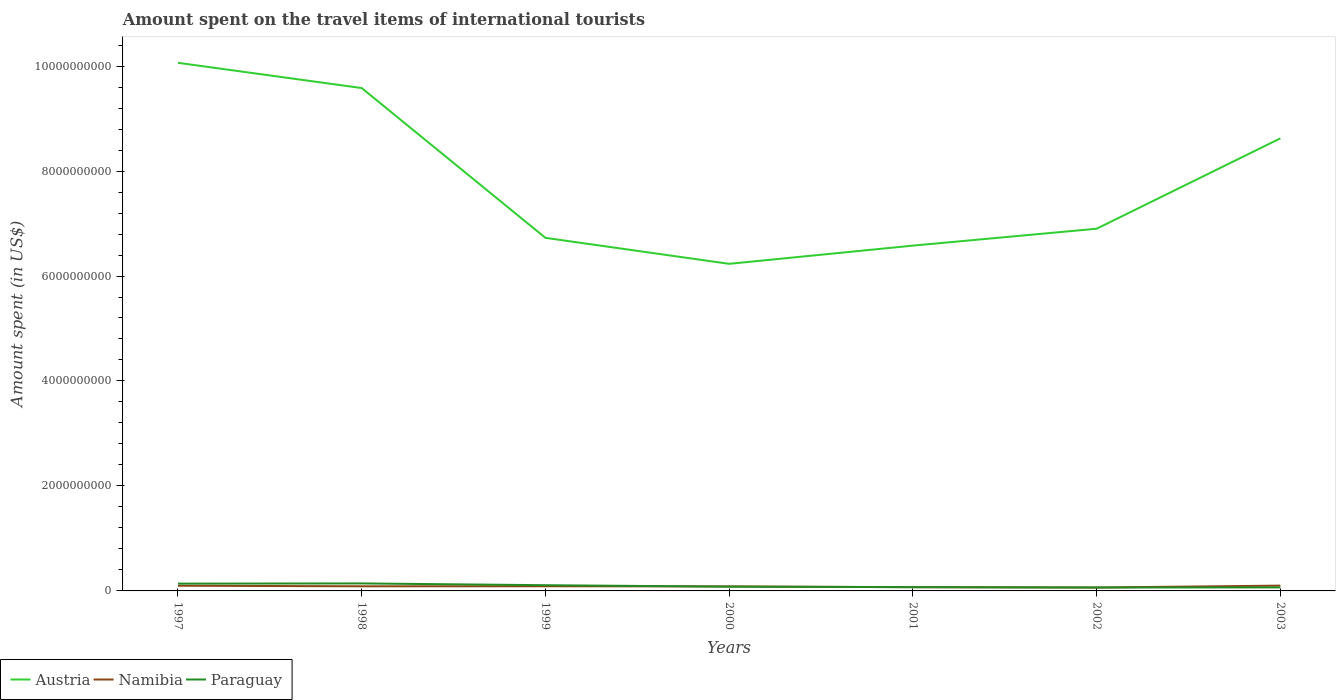How many different coloured lines are there?
Ensure brevity in your answer.  3. Does the line corresponding to Austria intersect with the line corresponding to Paraguay?
Your response must be concise. No. Across all years, what is the maximum amount spent on the travel items of international tourists in Austria?
Offer a very short reply. 6.23e+09. What is the total amount spent on the travel items of international tourists in Paraguay in the graph?
Your answer should be compact. 6.70e+07. What is the difference between the highest and the second highest amount spent on the travel items of international tourists in Paraguay?
Your answer should be very brief. 7.80e+07. What is the difference between the highest and the lowest amount spent on the travel items of international tourists in Austria?
Provide a short and direct response. 3. Is the amount spent on the travel items of international tourists in Paraguay strictly greater than the amount spent on the travel items of international tourists in Namibia over the years?
Provide a succinct answer. No. How many lines are there?
Provide a succinct answer. 3. How many years are there in the graph?
Offer a very short reply. 7. What is the difference between two consecutive major ticks on the Y-axis?
Make the answer very short. 2.00e+09. Does the graph contain any zero values?
Provide a short and direct response. No. Does the graph contain grids?
Offer a very short reply. No. Where does the legend appear in the graph?
Give a very brief answer. Bottom left. How many legend labels are there?
Offer a terse response. 3. How are the legend labels stacked?
Offer a terse response. Horizontal. What is the title of the graph?
Offer a terse response. Amount spent on the travel items of international tourists. What is the label or title of the X-axis?
Give a very brief answer. Years. What is the label or title of the Y-axis?
Offer a terse response. Amount spent (in US$). What is the Amount spent (in US$) in Austria in 1997?
Make the answer very short. 1.01e+1. What is the Amount spent (in US$) of Namibia in 1997?
Offer a terse response. 9.90e+07. What is the Amount spent (in US$) of Paraguay in 1997?
Your answer should be very brief. 1.39e+08. What is the Amount spent (in US$) in Austria in 1998?
Keep it short and to the point. 9.58e+09. What is the Amount spent (in US$) in Namibia in 1998?
Provide a short and direct response. 8.80e+07. What is the Amount spent (in US$) in Paraguay in 1998?
Ensure brevity in your answer.  1.43e+08. What is the Amount spent (in US$) in Austria in 1999?
Your answer should be very brief. 6.73e+09. What is the Amount spent (in US$) in Namibia in 1999?
Ensure brevity in your answer.  8.90e+07. What is the Amount spent (in US$) in Paraguay in 1999?
Offer a very short reply. 1.09e+08. What is the Amount spent (in US$) of Austria in 2000?
Keep it short and to the point. 6.23e+09. What is the Amount spent (in US$) in Namibia in 2000?
Your answer should be very brief. 8.60e+07. What is the Amount spent (in US$) of Paraguay in 2000?
Keep it short and to the point. 8.10e+07. What is the Amount spent (in US$) of Austria in 2001?
Offer a very short reply. 6.58e+09. What is the Amount spent (in US$) in Namibia in 2001?
Keep it short and to the point. 7.10e+07. What is the Amount spent (in US$) in Paraguay in 2001?
Your answer should be compact. 7.20e+07. What is the Amount spent (in US$) of Austria in 2002?
Offer a very short reply. 6.90e+09. What is the Amount spent (in US$) of Namibia in 2002?
Provide a succinct answer. 6.50e+07. What is the Amount spent (in US$) in Paraguay in 2002?
Give a very brief answer. 6.50e+07. What is the Amount spent (in US$) in Austria in 2003?
Your answer should be very brief. 8.62e+09. What is the Amount spent (in US$) in Namibia in 2003?
Provide a succinct answer. 1.01e+08. What is the Amount spent (in US$) in Paraguay in 2003?
Offer a very short reply. 6.70e+07. Across all years, what is the maximum Amount spent (in US$) of Austria?
Your answer should be compact. 1.01e+1. Across all years, what is the maximum Amount spent (in US$) of Namibia?
Offer a terse response. 1.01e+08. Across all years, what is the maximum Amount spent (in US$) of Paraguay?
Offer a very short reply. 1.43e+08. Across all years, what is the minimum Amount spent (in US$) of Austria?
Your response must be concise. 6.23e+09. Across all years, what is the minimum Amount spent (in US$) of Namibia?
Provide a short and direct response. 6.50e+07. Across all years, what is the minimum Amount spent (in US$) of Paraguay?
Offer a very short reply. 6.50e+07. What is the total Amount spent (in US$) in Austria in the graph?
Offer a very short reply. 5.47e+1. What is the total Amount spent (in US$) in Namibia in the graph?
Give a very brief answer. 5.99e+08. What is the total Amount spent (in US$) of Paraguay in the graph?
Your answer should be very brief. 6.76e+08. What is the difference between the Amount spent (in US$) in Austria in 1997 and that in 1998?
Keep it short and to the point. 4.81e+08. What is the difference between the Amount spent (in US$) in Namibia in 1997 and that in 1998?
Offer a terse response. 1.10e+07. What is the difference between the Amount spent (in US$) of Paraguay in 1997 and that in 1998?
Give a very brief answer. -4.00e+06. What is the difference between the Amount spent (in US$) in Austria in 1997 and that in 1999?
Your answer should be compact. 3.34e+09. What is the difference between the Amount spent (in US$) in Paraguay in 1997 and that in 1999?
Your response must be concise. 3.00e+07. What is the difference between the Amount spent (in US$) of Austria in 1997 and that in 2000?
Your answer should be compact. 3.83e+09. What is the difference between the Amount spent (in US$) in Namibia in 1997 and that in 2000?
Make the answer very short. 1.30e+07. What is the difference between the Amount spent (in US$) of Paraguay in 1997 and that in 2000?
Your response must be concise. 5.80e+07. What is the difference between the Amount spent (in US$) of Austria in 1997 and that in 2001?
Provide a succinct answer. 3.48e+09. What is the difference between the Amount spent (in US$) of Namibia in 1997 and that in 2001?
Your response must be concise. 2.80e+07. What is the difference between the Amount spent (in US$) of Paraguay in 1997 and that in 2001?
Offer a very short reply. 6.70e+07. What is the difference between the Amount spent (in US$) of Austria in 1997 and that in 2002?
Ensure brevity in your answer.  3.16e+09. What is the difference between the Amount spent (in US$) of Namibia in 1997 and that in 2002?
Keep it short and to the point. 3.40e+07. What is the difference between the Amount spent (in US$) in Paraguay in 1997 and that in 2002?
Offer a very short reply. 7.40e+07. What is the difference between the Amount spent (in US$) of Austria in 1997 and that in 2003?
Your response must be concise. 1.44e+09. What is the difference between the Amount spent (in US$) in Paraguay in 1997 and that in 2003?
Your response must be concise. 7.20e+07. What is the difference between the Amount spent (in US$) of Austria in 1998 and that in 1999?
Your answer should be very brief. 2.85e+09. What is the difference between the Amount spent (in US$) of Paraguay in 1998 and that in 1999?
Keep it short and to the point. 3.40e+07. What is the difference between the Amount spent (in US$) of Austria in 1998 and that in 2000?
Your response must be concise. 3.35e+09. What is the difference between the Amount spent (in US$) in Namibia in 1998 and that in 2000?
Keep it short and to the point. 2.00e+06. What is the difference between the Amount spent (in US$) in Paraguay in 1998 and that in 2000?
Offer a terse response. 6.20e+07. What is the difference between the Amount spent (in US$) of Austria in 1998 and that in 2001?
Offer a very short reply. 3.00e+09. What is the difference between the Amount spent (in US$) in Namibia in 1998 and that in 2001?
Your answer should be very brief. 1.70e+07. What is the difference between the Amount spent (in US$) in Paraguay in 1998 and that in 2001?
Provide a short and direct response. 7.10e+07. What is the difference between the Amount spent (in US$) in Austria in 1998 and that in 2002?
Provide a short and direct response. 2.68e+09. What is the difference between the Amount spent (in US$) of Namibia in 1998 and that in 2002?
Offer a terse response. 2.30e+07. What is the difference between the Amount spent (in US$) of Paraguay in 1998 and that in 2002?
Offer a very short reply. 7.80e+07. What is the difference between the Amount spent (in US$) in Austria in 1998 and that in 2003?
Offer a very short reply. 9.58e+08. What is the difference between the Amount spent (in US$) in Namibia in 1998 and that in 2003?
Your answer should be compact. -1.30e+07. What is the difference between the Amount spent (in US$) of Paraguay in 1998 and that in 2003?
Provide a succinct answer. 7.60e+07. What is the difference between the Amount spent (in US$) in Austria in 1999 and that in 2000?
Ensure brevity in your answer.  4.95e+08. What is the difference between the Amount spent (in US$) in Paraguay in 1999 and that in 2000?
Make the answer very short. 2.80e+07. What is the difference between the Amount spent (in US$) of Austria in 1999 and that in 2001?
Your answer should be compact. 1.48e+08. What is the difference between the Amount spent (in US$) of Namibia in 1999 and that in 2001?
Provide a succinct answer. 1.80e+07. What is the difference between the Amount spent (in US$) of Paraguay in 1999 and that in 2001?
Your response must be concise. 3.70e+07. What is the difference between the Amount spent (in US$) of Austria in 1999 and that in 2002?
Your response must be concise. -1.74e+08. What is the difference between the Amount spent (in US$) in Namibia in 1999 and that in 2002?
Make the answer very short. 2.40e+07. What is the difference between the Amount spent (in US$) in Paraguay in 1999 and that in 2002?
Your response must be concise. 4.40e+07. What is the difference between the Amount spent (in US$) of Austria in 1999 and that in 2003?
Provide a short and direct response. -1.90e+09. What is the difference between the Amount spent (in US$) of Namibia in 1999 and that in 2003?
Provide a succinct answer. -1.20e+07. What is the difference between the Amount spent (in US$) of Paraguay in 1999 and that in 2003?
Your answer should be compact. 4.20e+07. What is the difference between the Amount spent (in US$) in Austria in 2000 and that in 2001?
Provide a short and direct response. -3.47e+08. What is the difference between the Amount spent (in US$) in Namibia in 2000 and that in 2001?
Give a very brief answer. 1.50e+07. What is the difference between the Amount spent (in US$) of Paraguay in 2000 and that in 2001?
Provide a succinct answer. 9.00e+06. What is the difference between the Amount spent (in US$) of Austria in 2000 and that in 2002?
Give a very brief answer. -6.69e+08. What is the difference between the Amount spent (in US$) of Namibia in 2000 and that in 2002?
Provide a short and direct response. 2.10e+07. What is the difference between the Amount spent (in US$) of Paraguay in 2000 and that in 2002?
Keep it short and to the point. 1.60e+07. What is the difference between the Amount spent (in US$) of Austria in 2000 and that in 2003?
Provide a short and direct response. -2.39e+09. What is the difference between the Amount spent (in US$) in Namibia in 2000 and that in 2003?
Your answer should be very brief. -1.50e+07. What is the difference between the Amount spent (in US$) of Paraguay in 2000 and that in 2003?
Your answer should be compact. 1.40e+07. What is the difference between the Amount spent (in US$) in Austria in 2001 and that in 2002?
Your answer should be compact. -3.22e+08. What is the difference between the Amount spent (in US$) of Namibia in 2001 and that in 2002?
Provide a succinct answer. 6.00e+06. What is the difference between the Amount spent (in US$) of Austria in 2001 and that in 2003?
Your answer should be compact. -2.04e+09. What is the difference between the Amount spent (in US$) of Namibia in 2001 and that in 2003?
Provide a succinct answer. -3.00e+07. What is the difference between the Amount spent (in US$) in Austria in 2002 and that in 2003?
Give a very brief answer. -1.72e+09. What is the difference between the Amount spent (in US$) in Namibia in 2002 and that in 2003?
Provide a short and direct response. -3.60e+07. What is the difference between the Amount spent (in US$) of Austria in 1997 and the Amount spent (in US$) of Namibia in 1998?
Your answer should be very brief. 9.97e+09. What is the difference between the Amount spent (in US$) in Austria in 1997 and the Amount spent (in US$) in Paraguay in 1998?
Provide a short and direct response. 9.92e+09. What is the difference between the Amount spent (in US$) in Namibia in 1997 and the Amount spent (in US$) in Paraguay in 1998?
Ensure brevity in your answer.  -4.40e+07. What is the difference between the Amount spent (in US$) in Austria in 1997 and the Amount spent (in US$) in Namibia in 1999?
Offer a terse response. 9.97e+09. What is the difference between the Amount spent (in US$) of Austria in 1997 and the Amount spent (in US$) of Paraguay in 1999?
Your answer should be compact. 9.95e+09. What is the difference between the Amount spent (in US$) of Namibia in 1997 and the Amount spent (in US$) of Paraguay in 1999?
Give a very brief answer. -1.00e+07. What is the difference between the Amount spent (in US$) of Austria in 1997 and the Amount spent (in US$) of Namibia in 2000?
Ensure brevity in your answer.  9.98e+09. What is the difference between the Amount spent (in US$) of Austria in 1997 and the Amount spent (in US$) of Paraguay in 2000?
Make the answer very short. 9.98e+09. What is the difference between the Amount spent (in US$) in Namibia in 1997 and the Amount spent (in US$) in Paraguay in 2000?
Make the answer very short. 1.80e+07. What is the difference between the Amount spent (in US$) of Austria in 1997 and the Amount spent (in US$) of Namibia in 2001?
Keep it short and to the point. 9.99e+09. What is the difference between the Amount spent (in US$) in Austria in 1997 and the Amount spent (in US$) in Paraguay in 2001?
Offer a very short reply. 9.99e+09. What is the difference between the Amount spent (in US$) in Namibia in 1997 and the Amount spent (in US$) in Paraguay in 2001?
Make the answer very short. 2.70e+07. What is the difference between the Amount spent (in US$) in Austria in 1997 and the Amount spent (in US$) in Namibia in 2002?
Provide a short and direct response. 1.00e+1. What is the difference between the Amount spent (in US$) in Austria in 1997 and the Amount spent (in US$) in Paraguay in 2002?
Keep it short and to the point. 1.00e+1. What is the difference between the Amount spent (in US$) of Namibia in 1997 and the Amount spent (in US$) of Paraguay in 2002?
Your answer should be very brief. 3.40e+07. What is the difference between the Amount spent (in US$) of Austria in 1997 and the Amount spent (in US$) of Namibia in 2003?
Offer a terse response. 9.96e+09. What is the difference between the Amount spent (in US$) of Austria in 1997 and the Amount spent (in US$) of Paraguay in 2003?
Provide a succinct answer. 1.00e+1. What is the difference between the Amount spent (in US$) in Namibia in 1997 and the Amount spent (in US$) in Paraguay in 2003?
Provide a succinct answer. 3.20e+07. What is the difference between the Amount spent (in US$) of Austria in 1998 and the Amount spent (in US$) of Namibia in 1999?
Your answer should be very brief. 9.49e+09. What is the difference between the Amount spent (in US$) in Austria in 1998 and the Amount spent (in US$) in Paraguay in 1999?
Ensure brevity in your answer.  9.47e+09. What is the difference between the Amount spent (in US$) in Namibia in 1998 and the Amount spent (in US$) in Paraguay in 1999?
Make the answer very short. -2.10e+07. What is the difference between the Amount spent (in US$) in Austria in 1998 and the Amount spent (in US$) in Namibia in 2000?
Your response must be concise. 9.50e+09. What is the difference between the Amount spent (in US$) in Austria in 1998 and the Amount spent (in US$) in Paraguay in 2000?
Your answer should be compact. 9.50e+09. What is the difference between the Amount spent (in US$) in Austria in 1998 and the Amount spent (in US$) in Namibia in 2001?
Your answer should be compact. 9.51e+09. What is the difference between the Amount spent (in US$) of Austria in 1998 and the Amount spent (in US$) of Paraguay in 2001?
Provide a succinct answer. 9.51e+09. What is the difference between the Amount spent (in US$) in Namibia in 1998 and the Amount spent (in US$) in Paraguay in 2001?
Your response must be concise. 1.60e+07. What is the difference between the Amount spent (in US$) in Austria in 1998 and the Amount spent (in US$) in Namibia in 2002?
Offer a terse response. 9.52e+09. What is the difference between the Amount spent (in US$) in Austria in 1998 and the Amount spent (in US$) in Paraguay in 2002?
Offer a terse response. 9.52e+09. What is the difference between the Amount spent (in US$) in Namibia in 1998 and the Amount spent (in US$) in Paraguay in 2002?
Offer a very short reply. 2.30e+07. What is the difference between the Amount spent (in US$) in Austria in 1998 and the Amount spent (in US$) in Namibia in 2003?
Offer a very short reply. 9.48e+09. What is the difference between the Amount spent (in US$) in Austria in 1998 and the Amount spent (in US$) in Paraguay in 2003?
Make the answer very short. 9.51e+09. What is the difference between the Amount spent (in US$) in Namibia in 1998 and the Amount spent (in US$) in Paraguay in 2003?
Ensure brevity in your answer.  2.10e+07. What is the difference between the Amount spent (in US$) of Austria in 1999 and the Amount spent (in US$) of Namibia in 2000?
Keep it short and to the point. 6.64e+09. What is the difference between the Amount spent (in US$) of Austria in 1999 and the Amount spent (in US$) of Paraguay in 2000?
Provide a short and direct response. 6.65e+09. What is the difference between the Amount spent (in US$) in Austria in 1999 and the Amount spent (in US$) in Namibia in 2001?
Your answer should be compact. 6.66e+09. What is the difference between the Amount spent (in US$) of Austria in 1999 and the Amount spent (in US$) of Paraguay in 2001?
Offer a terse response. 6.66e+09. What is the difference between the Amount spent (in US$) in Namibia in 1999 and the Amount spent (in US$) in Paraguay in 2001?
Your response must be concise. 1.70e+07. What is the difference between the Amount spent (in US$) of Austria in 1999 and the Amount spent (in US$) of Namibia in 2002?
Ensure brevity in your answer.  6.66e+09. What is the difference between the Amount spent (in US$) of Austria in 1999 and the Amount spent (in US$) of Paraguay in 2002?
Your response must be concise. 6.66e+09. What is the difference between the Amount spent (in US$) in Namibia in 1999 and the Amount spent (in US$) in Paraguay in 2002?
Offer a very short reply. 2.40e+07. What is the difference between the Amount spent (in US$) in Austria in 1999 and the Amount spent (in US$) in Namibia in 2003?
Offer a very short reply. 6.63e+09. What is the difference between the Amount spent (in US$) of Austria in 1999 and the Amount spent (in US$) of Paraguay in 2003?
Make the answer very short. 6.66e+09. What is the difference between the Amount spent (in US$) in Namibia in 1999 and the Amount spent (in US$) in Paraguay in 2003?
Your answer should be very brief. 2.20e+07. What is the difference between the Amount spent (in US$) of Austria in 2000 and the Amount spent (in US$) of Namibia in 2001?
Your answer should be very brief. 6.16e+09. What is the difference between the Amount spent (in US$) in Austria in 2000 and the Amount spent (in US$) in Paraguay in 2001?
Your response must be concise. 6.16e+09. What is the difference between the Amount spent (in US$) in Namibia in 2000 and the Amount spent (in US$) in Paraguay in 2001?
Provide a short and direct response. 1.40e+07. What is the difference between the Amount spent (in US$) of Austria in 2000 and the Amount spent (in US$) of Namibia in 2002?
Make the answer very short. 6.17e+09. What is the difference between the Amount spent (in US$) in Austria in 2000 and the Amount spent (in US$) in Paraguay in 2002?
Your response must be concise. 6.17e+09. What is the difference between the Amount spent (in US$) of Namibia in 2000 and the Amount spent (in US$) of Paraguay in 2002?
Keep it short and to the point. 2.10e+07. What is the difference between the Amount spent (in US$) of Austria in 2000 and the Amount spent (in US$) of Namibia in 2003?
Your answer should be very brief. 6.13e+09. What is the difference between the Amount spent (in US$) of Austria in 2000 and the Amount spent (in US$) of Paraguay in 2003?
Provide a succinct answer. 6.16e+09. What is the difference between the Amount spent (in US$) of Namibia in 2000 and the Amount spent (in US$) of Paraguay in 2003?
Offer a very short reply. 1.90e+07. What is the difference between the Amount spent (in US$) of Austria in 2001 and the Amount spent (in US$) of Namibia in 2002?
Ensure brevity in your answer.  6.51e+09. What is the difference between the Amount spent (in US$) in Austria in 2001 and the Amount spent (in US$) in Paraguay in 2002?
Your response must be concise. 6.51e+09. What is the difference between the Amount spent (in US$) of Austria in 2001 and the Amount spent (in US$) of Namibia in 2003?
Offer a very short reply. 6.48e+09. What is the difference between the Amount spent (in US$) in Austria in 2001 and the Amount spent (in US$) in Paraguay in 2003?
Offer a terse response. 6.51e+09. What is the difference between the Amount spent (in US$) of Namibia in 2001 and the Amount spent (in US$) of Paraguay in 2003?
Make the answer very short. 4.00e+06. What is the difference between the Amount spent (in US$) of Austria in 2002 and the Amount spent (in US$) of Namibia in 2003?
Provide a short and direct response. 6.80e+09. What is the difference between the Amount spent (in US$) in Austria in 2002 and the Amount spent (in US$) in Paraguay in 2003?
Give a very brief answer. 6.83e+09. What is the difference between the Amount spent (in US$) in Namibia in 2002 and the Amount spent (in US$) in Paraguay in 2003?
Give a very brief answer. -2.00e+06. What is the average Amount spent (in US$) of Austria per year?
Offer a very short reply. 7.82e+09. What is the average Amount spent (in US$) of Namibia per year?
Keep it short and to the point. 8.56e+07. What is the average Amount spent (in US$) in Paraguay per year?
Provide a short and direct response. 9.66e+07. In the year 1997, what is the difference between the Amount spent (in US$) in Austria and Amount spent (in US$) in Namibia?
Provide a short and direct response. 9.96e+09. In the year 1997, what is the difference between the Amount spent (in US$) of Austria and Amount spent (in US$) of Paraguay?
Offer a terse response. 9.92e+09. In the year 1997, what is the difference between the Amount spent (in US$) of Namibia and Amount spent (in US$) of Paraguay?
Your answer should be very brief. -4.00e+07. In the year 1998, what is the difference between the Amount spent (in US$) of Austria and Amount spent (in US$) of Namibia?
Offer a very short reply. 9.49e+09. In the year 1998, what is the difference between the Amount spent (in US$) in Austria and Amount spent (in US$) in Paraguay?
Provide a short and direct response. 9.44e+09. In the year 1998, what is the difference between the Amount spent (in US$) of Namibia and Amount spent (in US$) of Paraguay?
Give a very brief answer. -5.50e+07. In the year 1999, what is the difference between the Amount spent (in US$) in Austria and Amount spent (in US$) in Namibia?
Provide a succinct answer. 6.64e+09. In the year 1999, what is the difference between the Amount spent (in US$) in Austria and Amount spent (in US$) in Paraguay?
Your answer should be very brief. 6.62e+09. In the year 1999, what is the difference between the Amount spent (in US$) of Namibia and Amount spent (in US$) of Paraguay?
Your answer should be very brief. -2.00e+07. In the year 2000, what is the difference between the Amount spent (in US$) in Austria and Amount spent (in US$) in Namibia?
Your response must be concise. 6.15e+09. In the year 2000, what is the difference between the Amount spent (in US$) in Austria and Amount spent (in US$) in Paraguay?
Provide a succinct answer. 6.15e+09. In the year 2000, what is the difference between the Amount spent (in US$) in Namibia and Amount spent (in US$) in Paraguay?
Ensure brevity in your answer.  5.00e+06. In the year 2001, what is the difference between the Amount spent (in US$) of Austria and Amount spent (in US$) of Namibia?
Offer a terse response. 6.51e+09. In the year 2001, what is the difference between the Amount spent (in US$) in Austria and Amount spent (in US$) in Paraguay?
Your answer should be very brief. 6.51e+09. In the year 2001, what is the difference between the Amount spent (in US$) in Namibia and Amount spent (in US$) in Paraguay?
Provide a short and direct response. -1.00e+06. In the year 2002, what is the difference between the Amount spent (in US$) in Austria and Amount spent (in US$) in Namibia?
Your response must be concise. 6.84e+09. In the year 2002, what is the difference between the Amount spent (in US$) of Austria and Amount spent (in US$) of Paraguay?
Your answer should be compact. 6.84e+09. In the year 2003, what is the difference between the Amount spent (in US$) in Austria and Amount spent (in US$) in Namibia?
Provide a short and direct response. 8.52e+09. In the year 2003, what is the difference between the Amount spent (in US$) in Austria and Amount spent (in US$) in Paraguay?
Give a very brief answer. 8.56e+09. In the year 2003, what is the difference between the Amount spent (in US$) in Namibia and Amount spent (in US$) in Paraguay?
Provide a succinct answer. 3.40e+07. What is the ratio of the Amount spent (in US$) of Austria in 1997 to that in 1998?
Provide a short and direct response. 1.05. What is the ratio of the Amount spent (in US$) of Namibia in 1997 to that in 1998?
Ensure brevity in your answer.  1.12. What is the ratio of the Amount spent (in US$) of Austria in 1997 to that in 1999?
Provide a succinct answer. 1.5. What is the ratio of the Amount spent (in US$) in Namibia in 1997 to that in 1999?
Ensure brevity in your answer.  1.11. What is the ratio of the Amount spent (in US$) of Paraguay in 1997 to that in 1999?
Make the answer very short. 1.28. What is the ratio of the Amount spent (in US$) of Austria in 1997 to that in 2000?
Ensure brevity in your answer.  1.61. What is the ratio of the Amount spent (in US$) in Namibia in 1997 to that in 2000?
Provide a succinct answer. 1.15. What is the ratio of the Amount spent (in US$) of Paraguay in 1997 to that in 2000?
Keep it short and to the point. 1.72. What is the ratio of the Amount spent (in US$) in Austria in 1997 to that in 2001?
Your answer should be very brief. 1.53. What is the ratio of the Amount spent (in US$) in Namibia in 1997 to that in 2001?
Your answer should be compact. 1.39. What is the ratio of the Amount spent (in US$) of Paraguay in 1997 to that in 2001?
Keep it short and to the point. 1.93. What is the ratio of the Amount spent (in US$) of Austria in 1997 to that in 2002?
Provide a succinct answer. 1.46. What is the ratio of the Amount spent (in US$) in Namibia in 1997 to that in 2002?
Keep it short and to the point. 1.52. What is the ratio of the Amount spent (in US$) of Paraguay in 1997 to that in 2002?
Give a very brief answer. 2.14. What is the ratio of the Amount spent (in US$) of Austria in 1997 to that in 2003?
Offer a very short reply. 1.17. What is the ratio of the Amount spent (in US$) in Namibia in 1997 to that in 2003?
Offer a terse response. 0.98. What is the ratio of the Amount spent (in US$) in Paraguay in 1997 to that in 2003?
Provide a succinct answer. 2.07. What is the ratio of the Amount spent (in US$) in Austria in 1998 to that in 1999?
Your answer should be very brief. 1.42. What is the ratio of the Amount spent (in US$) of Paraguay in 1998 to that in 1999?
Your response must be concise. 1.31. What is the ratio of the Amount spent (in US$) of Austria in 1998 to that in 2000?
Your answer should be very brief. 1.54. What is the ratio of the Amount spent (in US$) of Namibia in 1998 to that in 2000?
Ensure brevity in your answer.  1.02. What is the ratio of the Amount spent (in US$) of Paraguay in 1998 to that in 2000?
Your answer should be compact. 1.77. What is the ratio of the Amount spent (in US$) of Austria in 1998 to that in 2001?
Offer a terse response. 1.46. What is the ratio of the Amount spent (in US$) of Namibia in 1998 to that in 2001?
Provide a short and direct response. 1.24. What is the ratio of the Amount spent (in US$) in Paraguay in 1998 to that in 2001?
Provide a short and direct response. 1.99. What is the ratio of the Amount spent (in US$) of Austria in 1998 to that in 2002?
Make the answer very short. 1.39. What is the ratio of the Amount spent (in US$) in Namibia in 1998 to that in 2002?
Your answer should be very brief. 1.35. What is the ratio of the Amount spent (in US$) of Paraguay in 1998 to that in 2002?
Provide a short and direct response. 2.2. What is the ratio of the Amount spent (in US$) in Austria in 1998 to that in 2003?
Your response must be concise. 1.11. What is the ratio of the Amount spent (in US$) in Namibia in 1998 to that in 2003?
Give a very brief answer. 0.87. What is the ratio of the Amount spent (in US$) of Paraguay in 1998 to that in 2003?
Give a very brief answer. 2.13. What is the ratio of the Amount spent (in US$) of Austria in 1999 to that in 2000?
Your response must be concise. 1.08. What is the ratio of the Amount spent (in US$) of Namibia in 1999 to that in 2000?
Give a very brief answer. 1.03. What is the ratio of the Amount spent (in US$) in Paraguay in 1999 to that in 2000?
Offer a very short reply. 1.35. What is the ratio of the Amount spent (in US$) in Austria in 1999 to that in 2001?
Give a very brief answer. 1.02. What is the ratio of the Amount spent (in US$) in Namibia in 1999 to that in 2001?
Offer a terse response. 1.25. What is the ratio of the Amount spent (in US$) of Paraguay in 1999 to that in 2001?
Your response must be concise. 1.51. What is the ratio of the Amount spent (in US$) in Austria in 1999 to that in 2002?
Give a very brief answer. 0.97. What is the ratio of the Amount spent (in US$) of Namibia in 1999 to that in 2002?
Your answer should be compact. 1.37. What is the ratio of the Amount spent (in US$) of Paraguay in 1999 to that in 2002?
Give a very brief answer. 1.68. What is the ratio of the Amount spent (in US$) in Austria in 1999 to that in 2003?
Offer a very short reply. 0.78. What is the ratio of the Amount spent (in US$) of Namibia in 1999 to that in 2003?
Your response must be concise. 0.88. What is the ratio of the Amount spent (in US$) of Paraguay in 1999 to that in 2003?
Provide a succinct answer. 1.63. What is the ratio of the Amount spent (in US$) in Austria in 2000 to that in 2001?
Offer a terse response. 0.95. What is the ratio of the Amount spent (in US$) in Namibia in 2000 to that in 2001?
Your response must be concise. 1.21. What is the ratio of the Amount spent (in US$) of Austria in 2000 to that in 2002?
Provide a succinct answer. 0.9. What is the ratio of the Amount spent (in US$) in Namibia in 2000 to that in 2002?
Keep it short and to the point. 1.32. What is the ratio of the Amount spent (in US$) in Paraguay in 2000 to that in 2002?
Your response must be concise. 1.25. What is the ratio of the Amount spent (in US$) of Austria in 2000 to that in 2003?
Make the answer very short. 0.72. What is the ratio of the Amount spent (in US$) in Namibia in 2000 to that in 2003?
Provide a short and direct response. 0.85. What is the ratio of the Amount spent (in US$) of Paraguay in 2000 to that in 2003?
Your answer should be compact. 1.21. What is the ratio of the Amount spent (in US$) of Austria in 2001 to that in 2002?
Give a very brief answer. 0.95. What is the ratio of the Amount spent (in US$) in Namibia in 2001 to that in 2002?
Offer a terse response. 1.09. What is the ratio of the Amount spent (in US$) of Paraguay in 2001 to that in 2002?
Offer a terse response. 1.11. What is the ratio of the Amount spent (in US$) in Austria in 2001 to that in 2003?
Give a very brief answer. 0.76. What is the ratio of the Amount spent (in US$) of Namibia in 2001 to that in 2003?
Your answer should be very brief. 0.7. What is the ratio of the Amount spent (in US$) of Paraguay in 2001 to that in 2003?
Give a very brief answer. 1.07. What is the ratio of the Amount spent (in US$) in Austria in 2002 to that in 2003?
Your response must be concise. 0.8. What is the ratio of the Amount spent (in US$) in Namibia in 2002 to that in 2003?
Your answer should be very brief. 0.64. What is the ratio of the Amount spent (in US$) in Paraguay in 2002 to that in 2003?
Your answer should be compact. 0.97. What is the difference between the highest and the second highest Amount spent (in US$) in Austria?
Provide a short and direct response. 4.81e+08. What is the difference between the highest and the second highest Amount spent (in US$) of Namibia?
Your response must be concise. 2.00e+06. What is the difference between the highest and the lowest Amount spent (in US$) in Austria?
Ensure brevity in your answer.  3.83e+09. What is the difference between the highest and the lowest Amount spent (in US$) in Namibia?
Ensure brevity in your answer.  3.60e+07. What is the difference between the highest and the lowest Amount spent (in US$) of Paraguay?
Ensure brevity in your answer.  7.80e+07. 